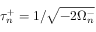Convert formula to latex. <formula><loc_0><loc_0><loc_500><loc_500>\tau _ { n } ^ { + } = 1 / \sqrt { - { 2 \Omega _ { n } ^ { - } } }</formula> 